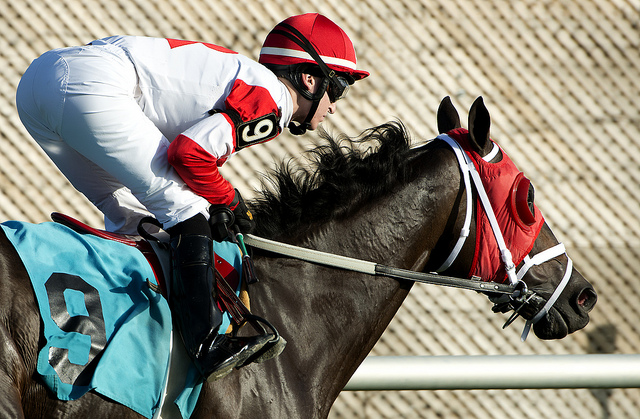Identify the text contained in this image. 9 9 